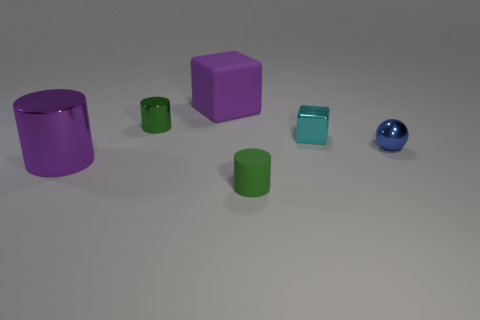Does the large rubber cube have the same color as the large metal thing?
Offer a very short reply. Yes. There is another cylinder that is the same color as the tiny metal cylinder; what is it made of?
Provide a succinct answer. Rubber. There is a green object in front of the big purple cylinder; is it the same shape as the purple thing that is behind the large shiny cylinder?
Offer a very short reply. No. What number of balls are either large purple shiny things or gray metallic things?
Make the answer very short. 0. Does the purple cylinder have the same material as the sphere?
Your answer should be very brief. Yes. How many other objects are there of the same color as the large matte thing?
Give a very brief answer. 1. The tiny green thing that is on the right side of the purple matte thing has what shape?
Offer a terse response. Cylinder. How many objects are either small things or tiny blue spheres?
Ensure brevity in your answer.  4. Do the purple metal cylinder and the thing that is in front of the large purple cylinder have the same size?
Ensure brevity in your answer.  No. How many other things are there of the same material as the blue sphere?
Your answer should be very brief. 3. 